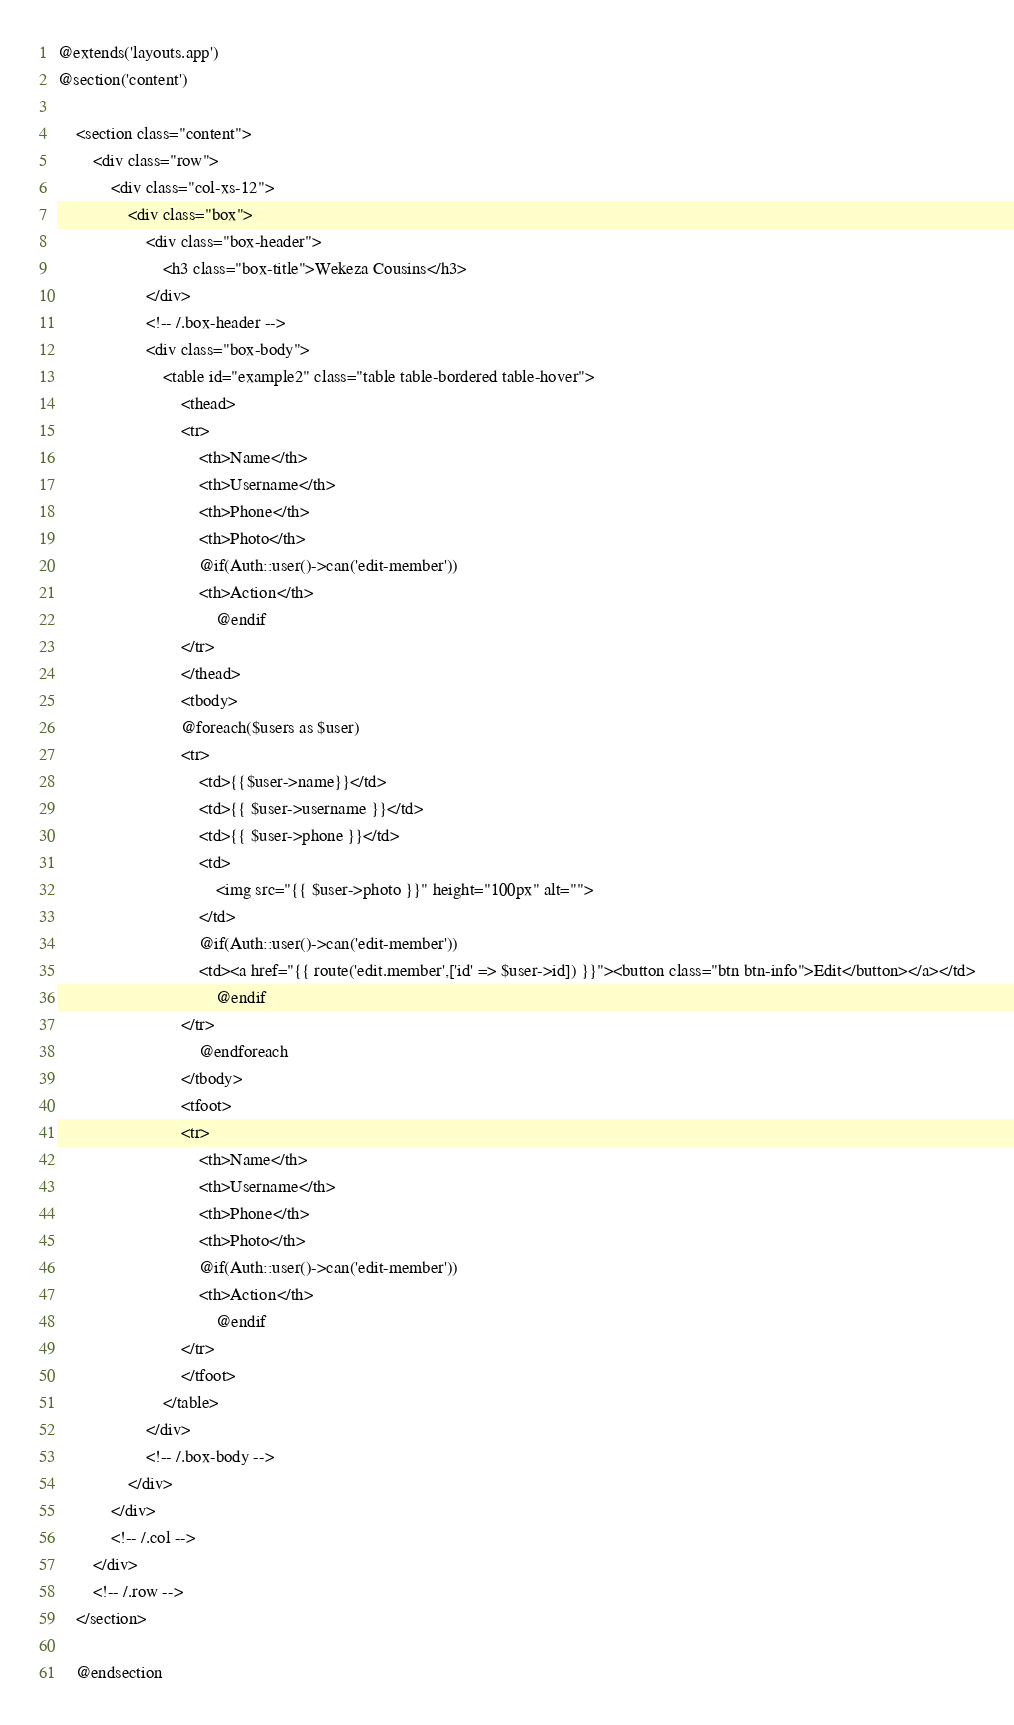Convert code to text. <code><loc_0><loc_0><loc_500><loc_500><_PHP_>@extends('layouts.app')
@section('content')

    <section class="content">
        <div class="row">
            <div class="col-xs-12">
                <div class="box">
                    <div class="box-header">
                        <h3 class="box-title">Wekeza Cousins</h3>
                    </div>
                    <!-- /.box-header -->
                    <div class="box-body">
                        <table id="example2" class="table table-bordered table-hover">
                            <thead>
                            <tr>
                                <th>Name</th>
                                <th>Username</th>
                                <th>Phone</th>
                                <th>Photo</th>
                                @if(Auth::user()->can('edit-member'))
                                <th>Action</th>
                                    @endif
                            </tr>
                            </thead>
                            <tbody>
                            @foreach($users as $user)
                            <tr>
                                <td>{{$user->name}}</td>
                                <td>{{ $user->username }}</td>
                                <td>{{ $user->phone }}</td>
                                <td>
                                    <img src="{{ $user->photo }}" height="100px" alt="">
                                </td>
                                @if(Auth::user()->can('edit-member'))
                                <td><a href="{{ route('edit.member',['id' => $user->id]) }}"><button class="btn btn-info">Edit</button></a></td>
                                    @endif
                            </tr>
                                @endforeach
                            </tbody>
                            <tfoot>
                            <tr>
                                <th>Name</th>
                                <th>Username</th>
                                <th>Phone</th>
                                <th>Photo</th>
                                @if(Auth::user()->can('edit-member'))
                                <th>Action</th>
                                    @endif
                            </tr>
                            </tfoot>
                        </table>
                    </div>
                    <!-- /.box-body -->
                </div>
            </div>
            <!-- /.col -->
        </div>
        <!-- /.row -->
    </section>

    @endsection
</code> 